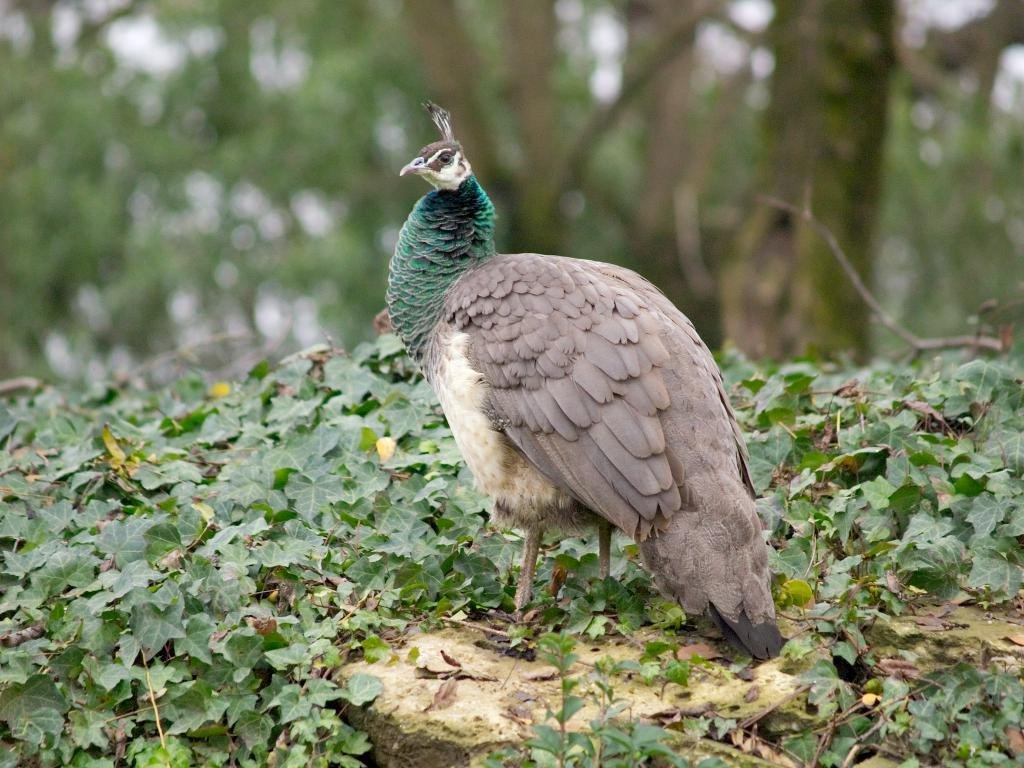What type of animal is in the image? There is a bird in the image. Can you describe the bird's appearance? The bird has brown, white, black, and green colors. What type of vegetation is present in the image? There are green color leaves in the image. What else can be seen in the image besides the bird and leaves? There are trees in the image. What type of tomatoes can be seen hanging from the trees in the image? There are no tomatoes present in the image; it features a bird with brown, white, black, and green colors, green leaves, and trees. Is there a band playing music in the image? There is no band present in the image. 